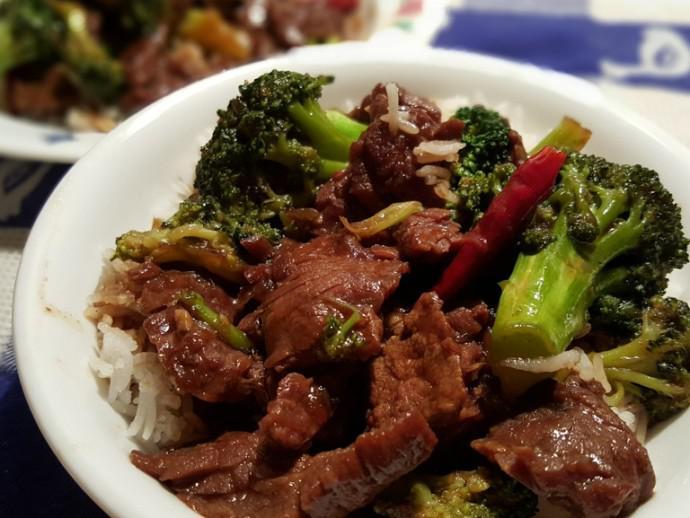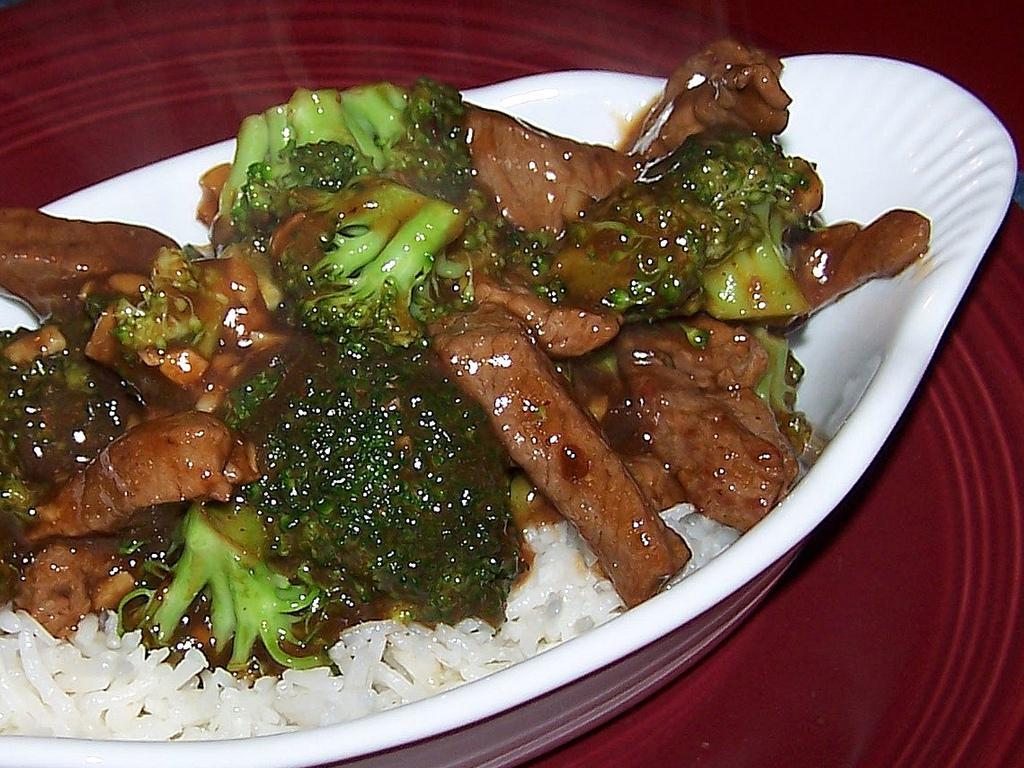The first image is the image on the left, the second image is the image on the right. Assess this claim about the two images: "Right image shows a white plate containing an entree that includes white rice and broccoli.". Correct or not? Answer yes or no. Yes. The first image is the image on the left, the second image is the image on the right. Assess this claim about the two images: "Two beef and broccoli meals are served on white plates, one with rice and one with no rice.". Correct or not? Answer yes or no. No. The first image is the image on the left, the second image is the image on the right. Given the left and right images, does the statement "Meat and brocolli is served over rice." hold true? Answer yes or no. Yes. 